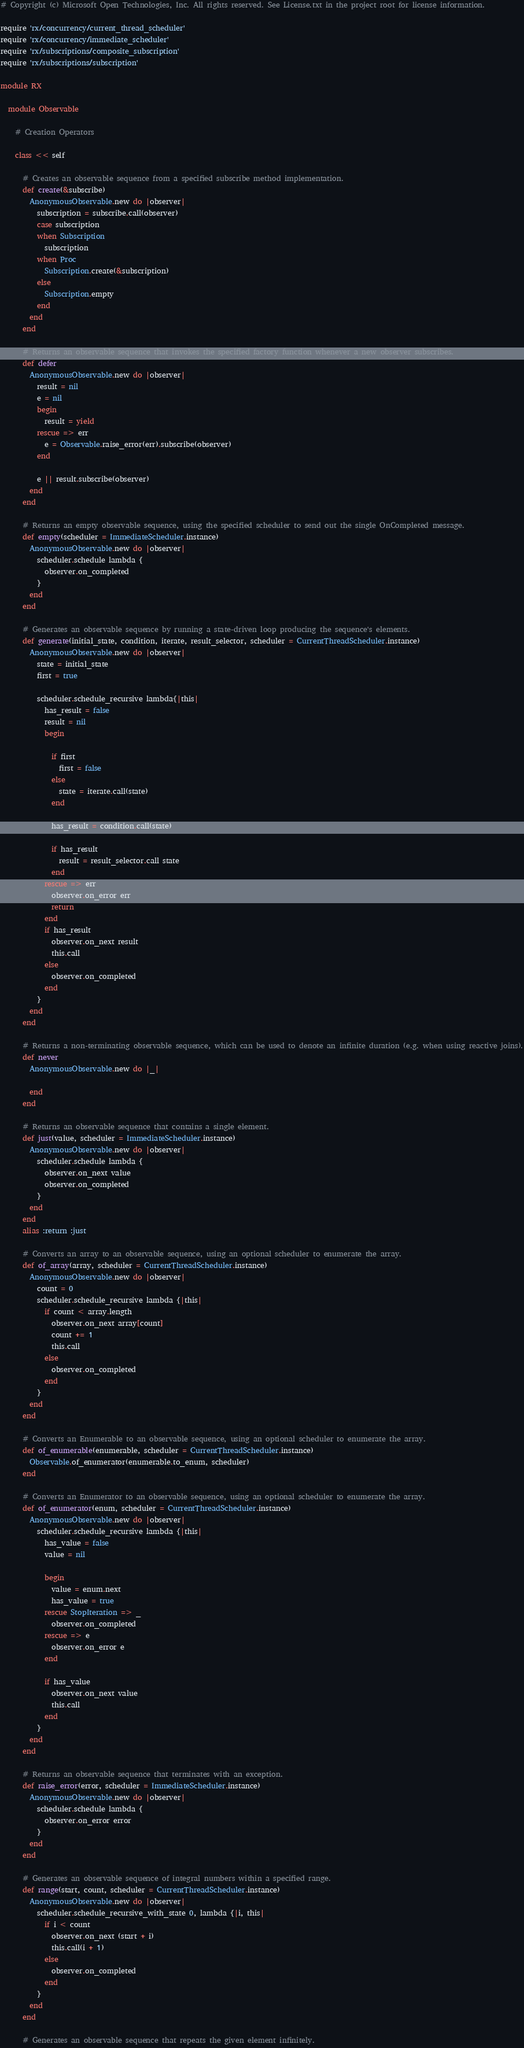<code> <loc_0><loc_0><loc_500><loc_500><_Ruby_># Copyright (c) Microsoft Open Technologies, Inc. All rights reserved. See License.txt in the project root for license information.

require 'rx/concurrency/current_thread_scheduler'
require 'rx/concurrency/immediate_scheduler'
require 'rx/subscriptions/composite_subscription'
require 'rx/subscriptions/subscription'

module RX

  module Observable

    # Creation Operators

    class << self

      # Creates an observable sequence from a specified subscribe method implementation.
      def create(&subscribe)
        AnonymousObservable.new do |observer|
          subscription = subscribe.call(observer)
          case subscription
          when Subscription
            subscription
          when Proc
            Subscription.create(&subscription)
          else
            Subscription.empty
          end
        end
      end

      # Returns an observable sequence that invokes the specified factory function whenever a new observer subscribes.
      def defer
        AnonymousObservable.new do |observer|
          result = nil
          e = nil
          begin
            result = yield
          rescue => err
            e = Observable.raise_error(err).subscribe(observer)
          end

          e || result.subscribe(observer)
        end
      end

      # Returns an empty observable sequence, using the specified scheduler to send out the single OnCompleted message.
      def empty(scheduler = ImmediateScheduler.instance)
        AnonymousObservable.new do |observer|
          scheduler.schedule lambda {
            observer.on_completed
          }
        end
      end

      # Generates an observable sequence by running a state-driven loop producing the sequence's elements.
      def generate(initial_state, condition, iterate, result_selector, scheduler = CurrentThreadScheduler.instance)
        AnonymousObservable.new do |observer|
          state = initial_state
          first = true
          
          scheduler.schedule_recursive lambda{|this|
            has_result = false
            result = nil
            begin

              if first
                first = false
              else
                state = iterate.call(state)
              end

              has_result = condition.call(state)

              if has_result
                result = result_selector.call state
              end
            rescue => err
              observer.on_error err
              return
            end
            if has_result
              observer.on_next result
              this.call
            else
              observer.on_completed
            end
          }
        end
      end    

      # Returns a non-terminating observable sequence, which can be used to denote an infinite duration (e.g. when using reactive joins).
      def never
        AnonymousObservable.new do |_|

        end
      end

      # Returns an observable sequence that contains a single element.
      def just(value, scheduler = ImmediateScheduler.instance)
        AnonymousObservable.new do |observer|
          scheduler.schedule lambda {
            observer.on_next value
            observer.on_completed
          }
        end
      end
      alias :return :just

      # Converts an array to an observable sequence, using an optional scheduler to enumerate the array.
      def of_array(array, scheduler = CurrentThreadScheduler.instance)
        AnonymousObservable.new do |observer|
          count = 0
          scheduler.schedule_recursive lambda {|this|
            if count < array.length
              observer.on_next array[count]
              count += 1
              this.call
            else
              observer.on_completed
            end
          }
        end
      end

      # Converts an Enumerable to an observable sequence, using an optional scheduler to enumerate the array.
      def of_enumerable(enumerable, scheduler = CurrentThreadScheduler.instance)
        Observable.of_enumerator(enumerable.to_enum, scheduler)
      end

      # Converts an Enumerator to an observable sequence, using an optional scheduler to enumerate the array.
      def of_enumerator(enum, scheduler = CurrentThreadScheduler.instance)
        AnonymousObservable.new do |observer|
          scheduler.schedule_recursive lambda {|this|
            has_value = false
            value = nil

            begin
              value = enum.next
              has_value = true
            rescue StopIteration => _
              observer.on_completed
            rescue => e
              observer.on_error e
            end

            if has_value
              observer.on_next value
              this.call
            end
          }
        end
      end

      # Returns an observable sequence that terminates with an exception.
      def raise_error(error, scheduler = ImmediateScheduler.instance)
        AnonymousObservable.new do |observer|
          scheduler.schedule lambda {
            observer.on_error error
          }
        end
      end

      # Generates an observable sequence of integral numbers within a specified range.
      def range(start, count, scheduler = CurrentThreadScheduler.instance)
        AnonymousObservable.new do |observer|
          scheduler.schedule_recursive_with_state 0, lambda {|i, this|
            if i < count
              observer.on_next (start + i)
              this.call(i + 1)
            else
              observer.on_completed
            end
          }
        end
      end

      # Generates an observable sequence that repeats the given element infinitely.</code> 